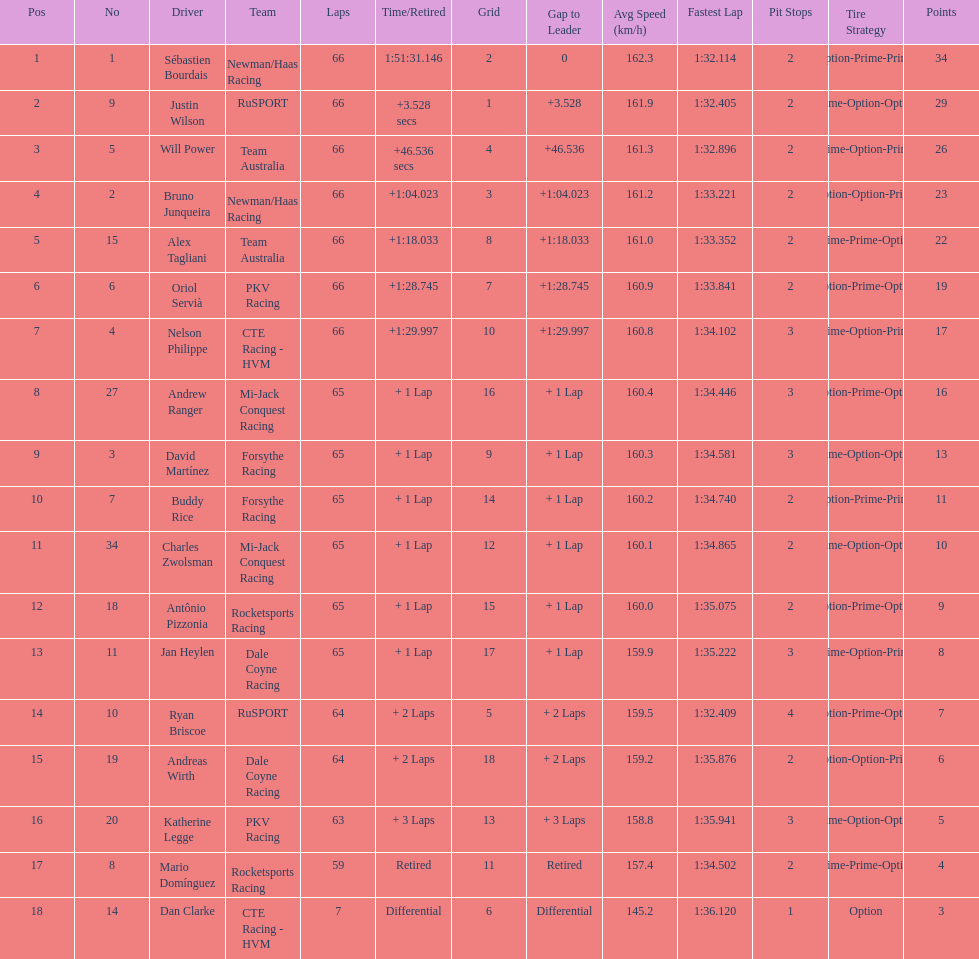Which country had more drivers representing them, the us or germany? Tie. 